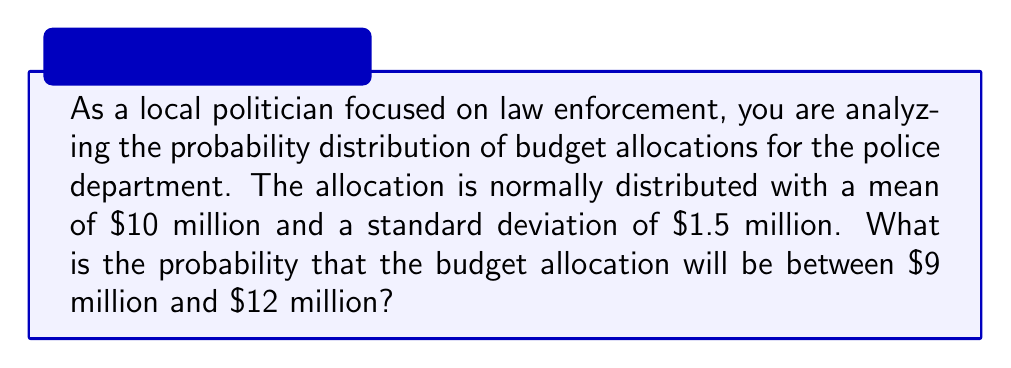Can you solve this math problem? To solve this problem, we need to use the properties of the normal distribution and the concept of z-scores.

1. Given information:
   - The budget allocation follows a normal distribution
   - Mean (μ) = $10 million
   - Standard deviation (σ) = $1.5 million
   - We want to find P($9 million < X < $12 million)

2. Calculate the z-scores for the lower and upper bounds:
   - For $9 million: $z_1 = \frac{9 - 10}{1.5} = -\frac{2}{3} \approx -0.67$
   - For $12 million: $z_2 = \frac{12 - 10}{1.5} = \frac{4}{3} \approx 1.33$

3. Use the standard normal distribution table or a calculator to find the area under the curve:
   - P(Z < -0.67) ≈ 0.2514
   - P(Z < 1.33) ≈ 0.9082

4. Calculate the probability:
   P($9 million < X < $12 million) = P(-0.67 < Z < 1.33)
   = P(Z < 1.33) - P(Z < -0.67)
   ≈ 0.9082 - 0.2514
   ≈ 0.6568

Therefore, the probability that the budget allocation will be between $9 million and $12 million is approximately 0.6568 or 65.68%.
Answer: The probability that the budget allocation will be between $9 million and $12 million is approximately 0.6568 or 65.68%. 